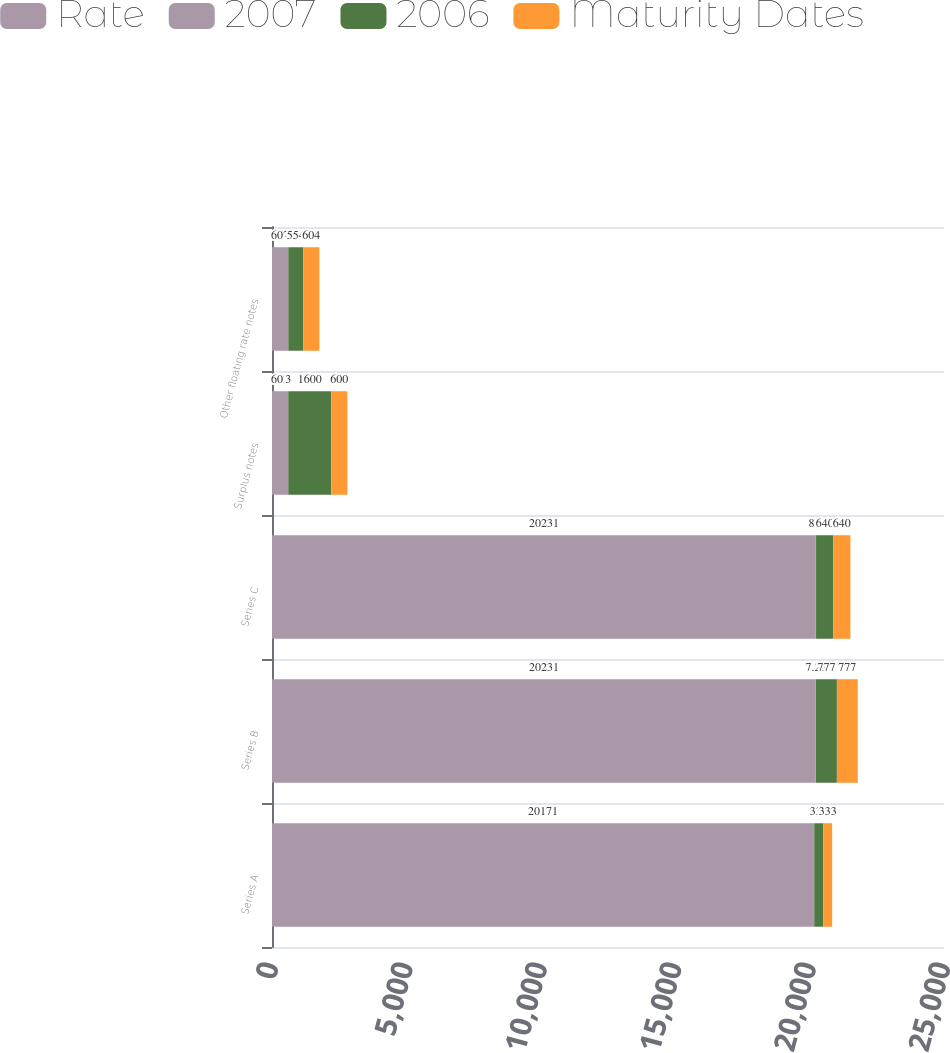Convert chart to OTSL. <chart><loc_0><loc_0><loc_500><loc_500><stacked_bar_chart><ecel><fcel>Series A<fcel>Series B<fcel>Series C<fcel>Surplus notes<fcel>Other floating rate notes<nl><fcel>Rate<fcel>20171<fcel>20231<fcel>20231<fcel>602<fcel>602<nl><fcel>2007<fcel>2<fcel>7.25<fcel>8.7<fcel>3<fcel>4<nl><fcel>2006<fcel>333<fcel>777<fcel>640<fcel>1600<fcel>554<nl><fcel>Maturity Dates<fcel>333<fcel>777<fcel>640<fcel>600<fcel>604<nl></chart> 